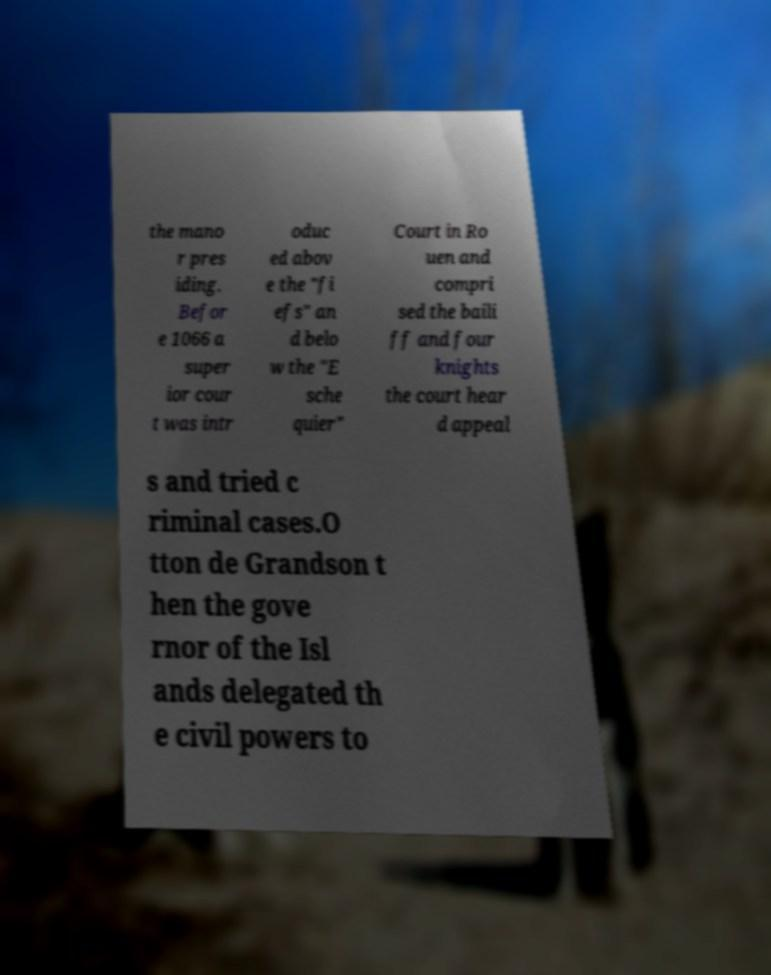Can you accurately transcribe the text from the provided image for me? the mano r pres iding. Befor e 1066 a super ior cour t was intr oduc ed abov e the "fi efs" an d belo w the "E sche quier" Court in Ro uen and compri sed the baili ff and four knights the court hear d appeal s and tried c riminal cases.O tton de Grandson t hen the gove rnor of the Isl ands delegated th e civil powers to 